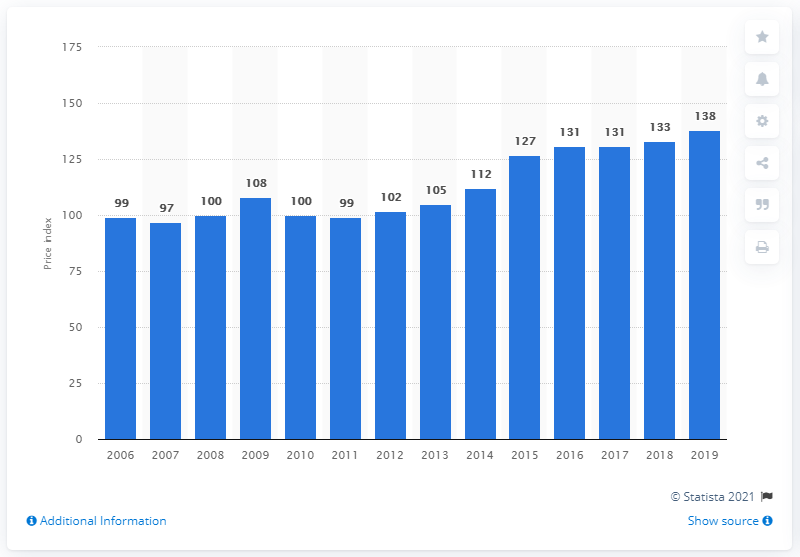Point out several critical features in this image. The price index of machinery and equipment used in the construction industry in 2019 was 138. 